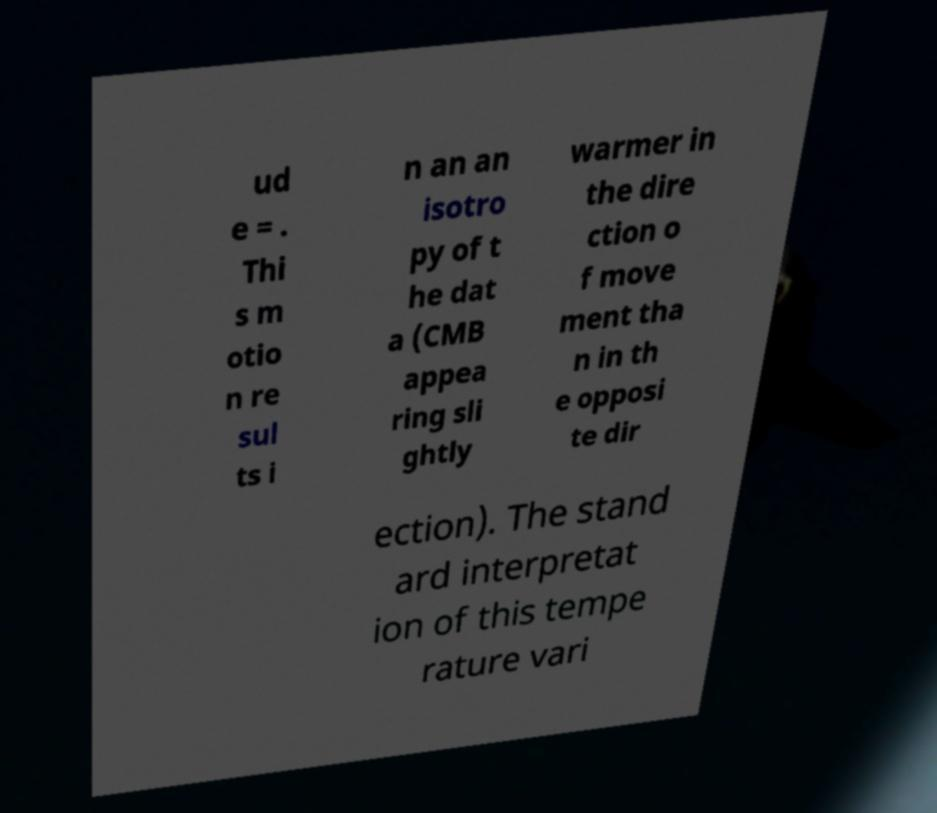I need the written content from this picture converted into text. Can you do that? ud e = . Thi s m otio n re sul ts i n an an isotro py of t he dat a (CMB appea ring sli ghtly warmer in the dire ction o f move ment tha n in th e opposi te dir ection). The stand ard interpretat ion of this tempe rature vari 